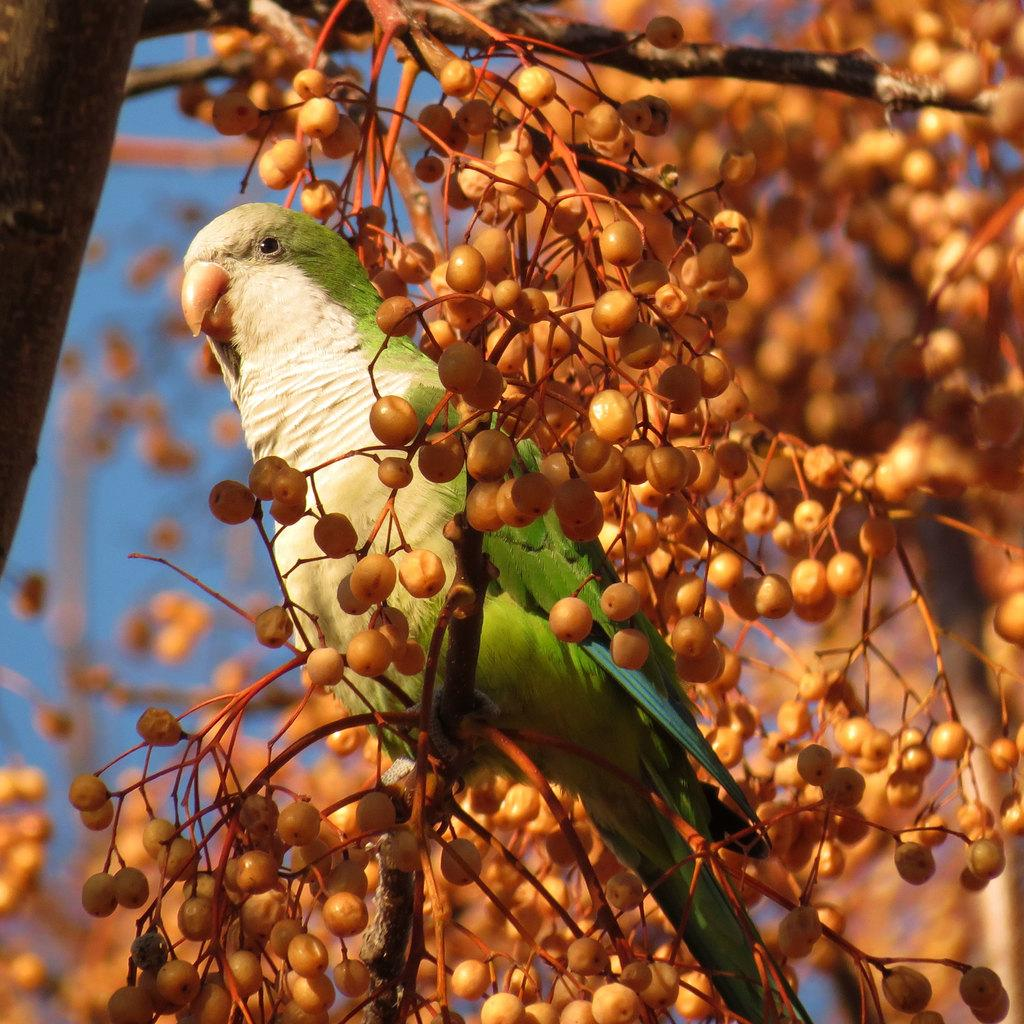What type of animal is in the image? There is a parrot in the image. Where is the parrot located? The parrot is on a tree. What else can be seen in the foreground of the image? There are fruits in the foreground of the image. What is the aftermath of the power outage in the image? There is no mention of a power outage or its aftermath in the image. 